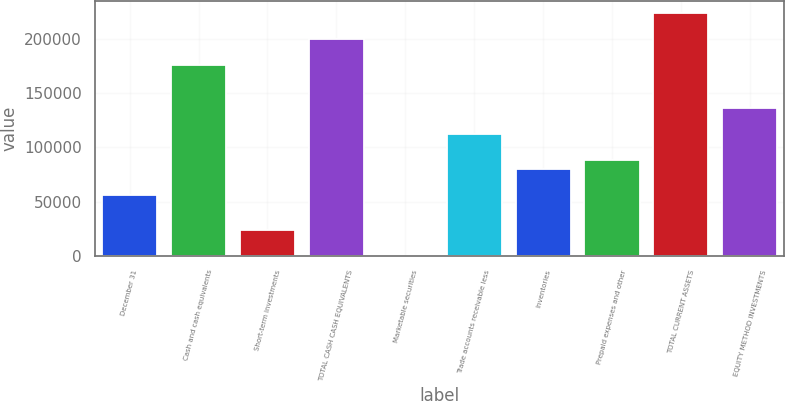<chart> <loc_0><loc_0><loc_500><loc_500><bar_chart><fcel>December 31<fcel>Cash and cash equivalents<fcel>Short-term investments<fcel>TOTAL CASH CASH EQUIVALENTS<fcel>Marketable securities<fcel>Trade accounts receivable less<fcel>Inventories<fcel>Prepaid expenses and other<fcel>TOTAL CURRENT ASSETS<fcel>EQUITY METHOD INVESTMENTS<nl><fcel>56025<fcel>175770<fcel>24093<fcel>199719<fcel>144<fcel>111906<fcel>79974<fcel>87957<fcel>223668<fcel>135855<nl></chart> 